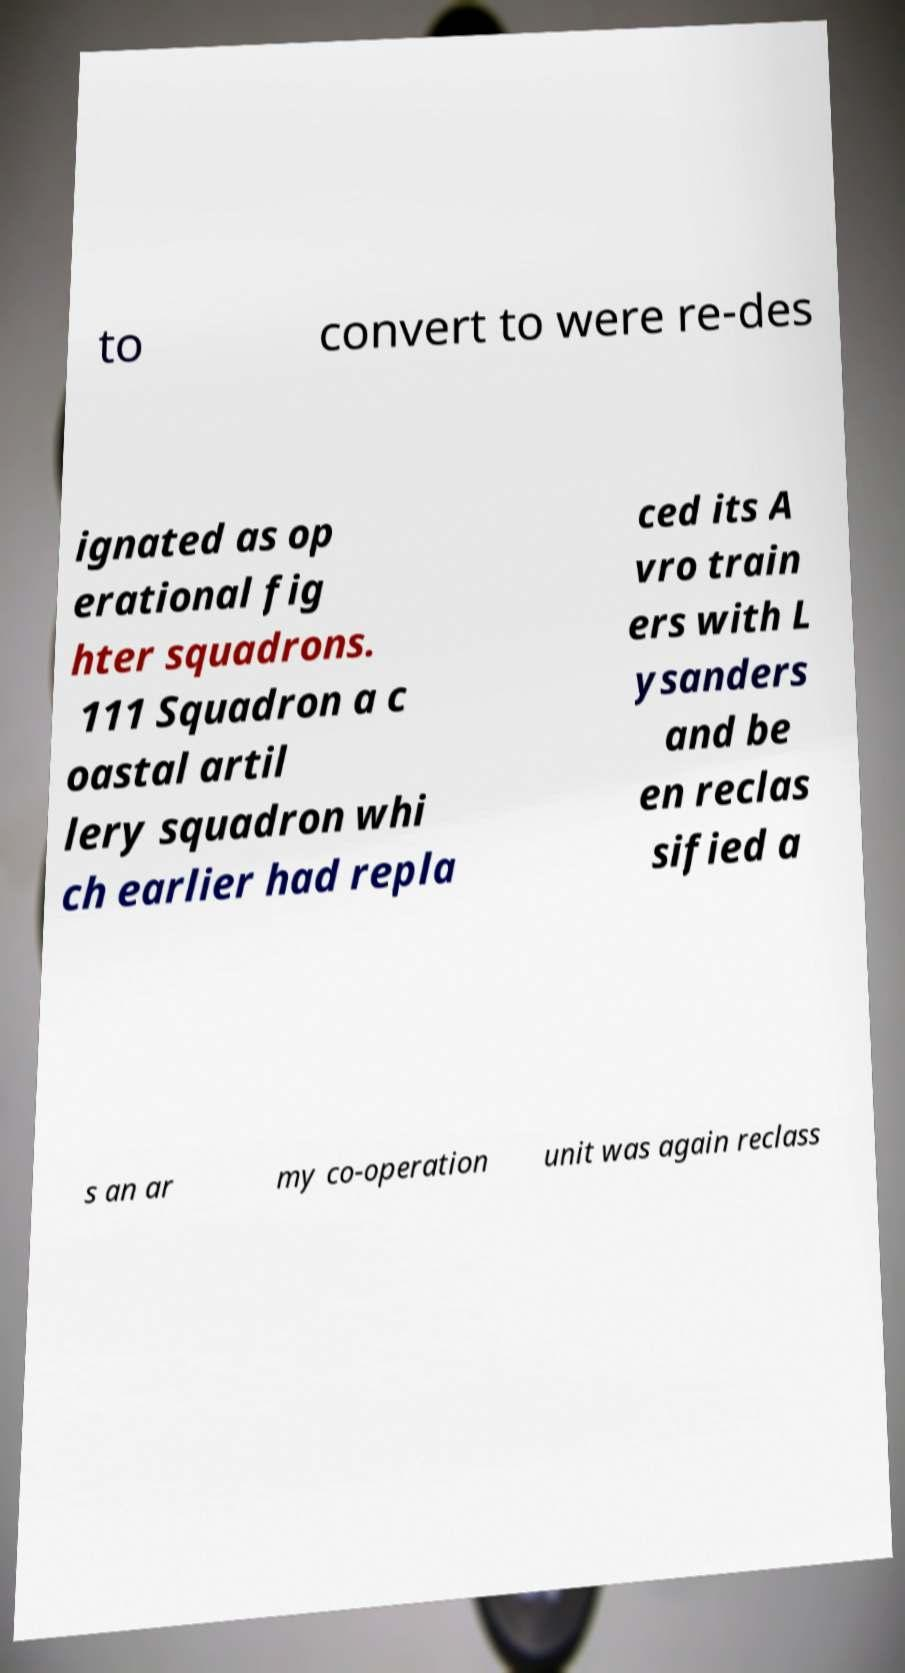Can you read and provide the text displayed in the image?This photo seems to have some interesting text. Can you extract and type it out for me? to convert to were re-des ignated as op erational fig hter squadrons. 111 Squadron a c oastal artil lery squadron whi ch earlier had repla ced its A vro train ers with L ysanders and be en reclas sified a s an ar my co-operation unit was again reclass 